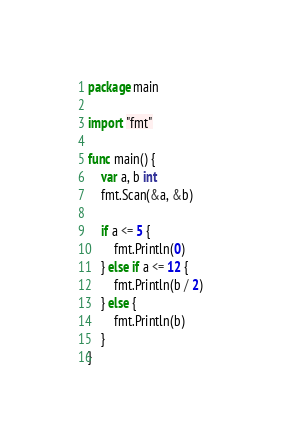<code> <loc_0><loc_0><loc_500><loc_500><_Go_>package main

import "fmt"

func main() {
	var a, b int
	fmt.Scan(&a, &b)

	if a <= 5 {
		fmt.Println(0)
	} else if a <= 12 {
		fmt.Println(b / 2)
	} else {
		fmt.Println(b)
	}
}
</code> 